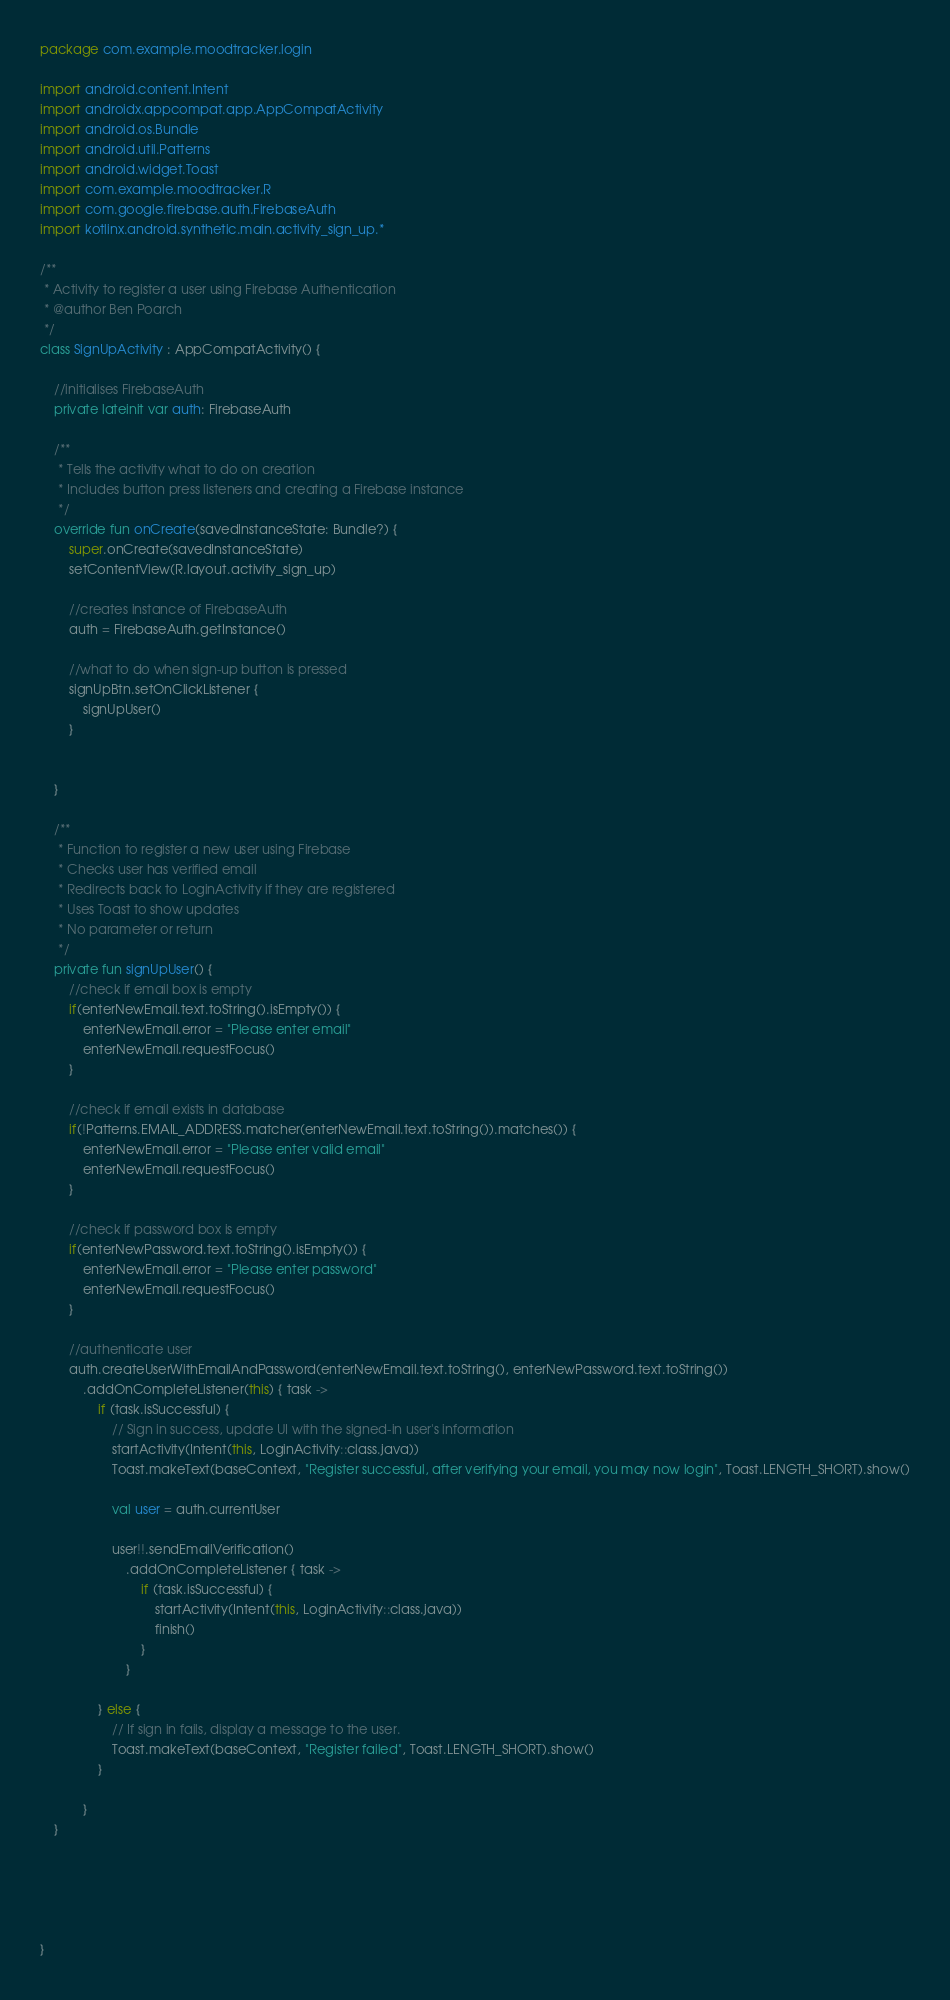<code> <loc_0><loc_0><loc_500><loc_500><_Kotlin_>package com.example.moodtracker.login

import android.content.Intent
import androidx.appcompat.app.AppCompatActivity
import android.os.Bundle
import android.util.Patterns
import android.widget.Toast
import com.example.moodtracker.R
import com.google.firebase.auth.FirebaseAuth
import kotlinx.android.synthetic.main.activity_sign_up.*

/**
 * Activity to register a user using Firebase Authentication
 * @author Ben Poarch
 */
class SignUpActivity : AppCompatActivity() {

    //initialises FirebaseAuth
    private lateinit var auth: FirebaseAuth

    /**
     * Tells the activity what to do on creation
     * Includes button press listeners and creating a Firebase instance
     */
    override fun onCreate(savedInstanceState: Bundle?) {
        super.onCreate(savedInstanceState)
        setContentView(R.layout.activity_sign_up)

        //creates instance of FirebaseAuth
        auth = FirebaseAuth.getInstance()

        //what to do when sign-up button is pressed
        signUpBtn.setOnClickListener {
            signUpUser()
        }


    }

    /**
     * Function to register a new user using Firebase
     * Checks user has verified email
     * Redirects back to LoginActivity if they are registered
     * Uses Toast to show updates
     * No parameter or return
     */
    private fun signUpUser() {
        //check if email box is empty
        if(enterNewEmail.text.toString().isEmpty()) {
            enterNewEmail.error = "Please enter email"
            enterNewEmail.requestFocus()
        }

        //check if email exists in database
        if(!Patterns.EMAIL_ADDRESS.matcher(enterNewEmail.text.toString()).matches()) {
            enterNewEmail.error = "Please enter valid email"
            enterNewEmail.requestFocus()
        }

        //check if password box is empty
        if(enterNewPassword.text.toString().isEmpty()) {
            enterNewEmail.error = "Please enter password"
            enterNewEmail.requestFocus()
        }

        //authenticate user
        auth.createUserWithEmailAndPassword(enterNewEmail.text.toString(), enterNewPassword.text.toString())
            .addOnCompleteListener(this) { task ->
                if (task.isSuccessful) {
                    // Sign in success, update UI with the signed-in user's information
                    startActivity(Intent(this, LoginActivity::class.java))
                    Toast.makeText(baseContext, "Register successful, after verifying your email, you may now login", Toast.LENGTH_SHORT).show()

                    val user = auth.currentUser

                    user!!.sendEmailVerification()
                        .addOnCompleteListener { task ->
                            if (task.isSuccessful) {
                                startActivity(Intent(this, LoginActivity::class.java))
                                finish()
                            }
                        }

                } else {
                    // If sign in fails, display a message to the user.
                    Toast.makeText(baseContext, "Register failed", Toast.LENGTH_SHORT).show()
                }

            }
    }





}</code> 